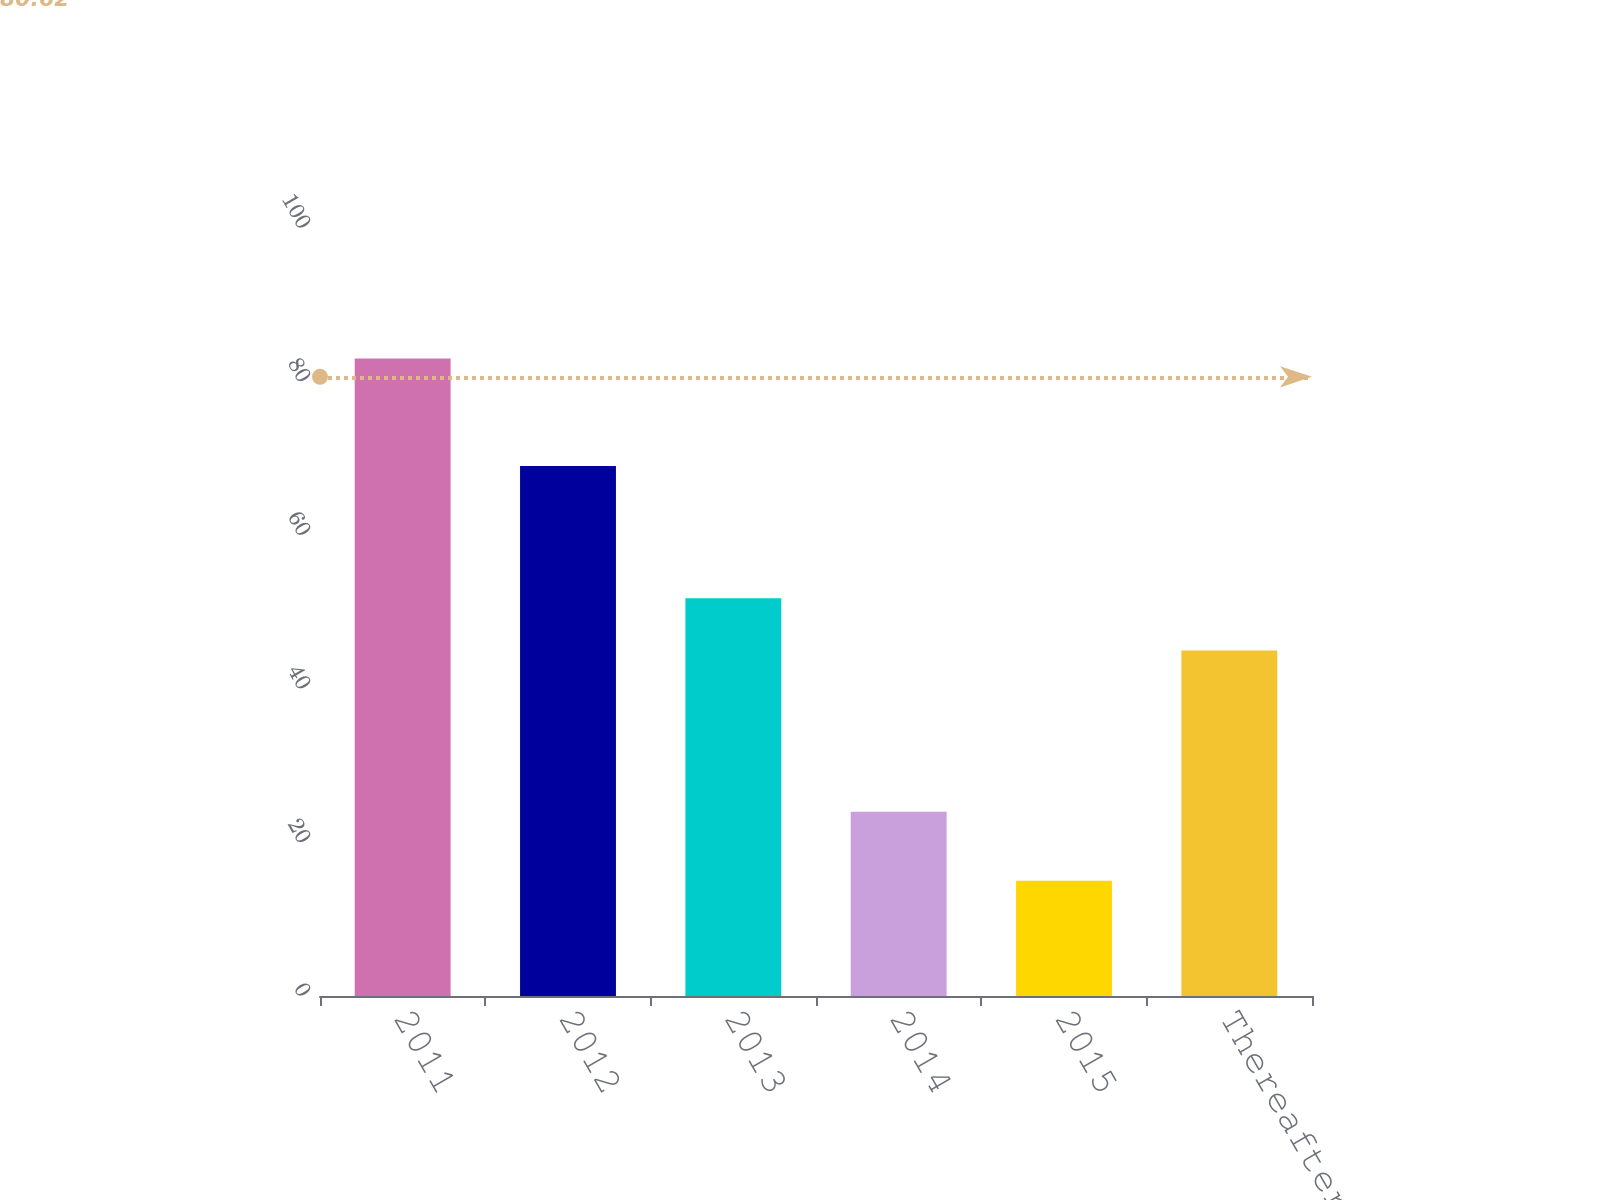<chart> <loc_0><loc_0><loc_500><loc_500><bar_chart><fcel>2011<fcel>2012<fcel>2013<fcel>2014<fcel>2015<fcel>Thereafter<nl><fcel>83<fcel>69<fcel>51.8<fcel>24<fcel>15<fcel>45<nl></chart> 